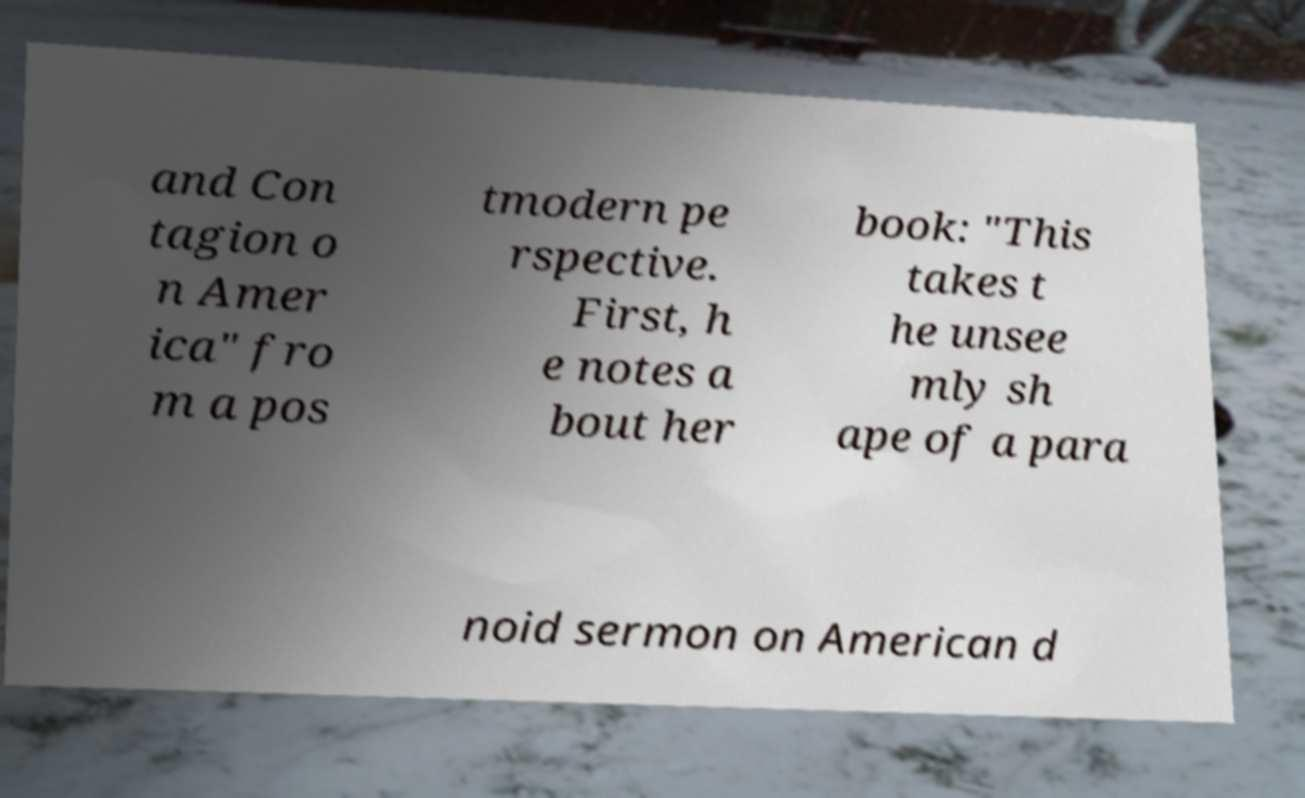Can you read and provide the text displayed in the image?This photo seems to have some interesting text. Can you extract and type it out for me? and Con tagion o n Amer ica" fro m a pos tmodern pe rspective. First, h e notes a bout her book: "This takes t he unsee mly sh ape of a para noid sermon on American d 